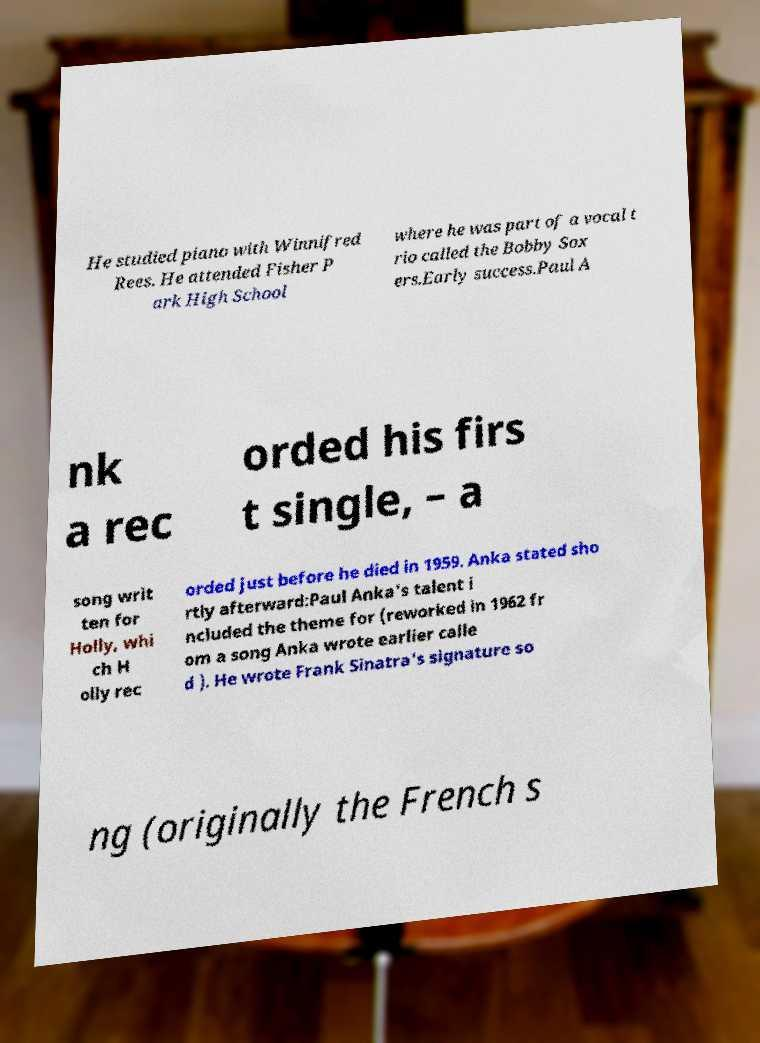Could you extract and type out the text from this image? He studied piano with Winnifred Rees. He attended Fisher P ark High School where he was part of a vocal t rio called the Bobby Sox ers.Early success.Paul A nk a rec orded his firs t single, – a song writ ten for Holly, whi ch H olly rec orded just before he died in 1959. Anka stated sho rtly afterward:Paul Anka's talent i ncluded the theme for (reworked in 1962 fr om a song Anka wrote earlier calle d ). He wrote Frank Sinatra's signature so ng (originally the French s 